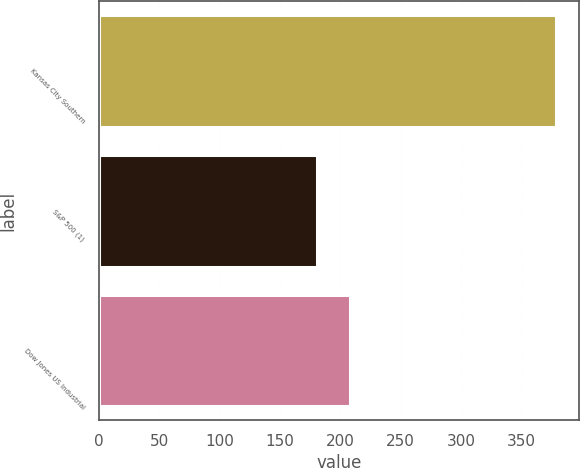Convert chart. <chart><loc_0><loc_0><loc_500><loc_500><bar_chart><fcel>Kansas City Southern<fcel>S&P 500 (1)<fcel>Dow Jones US Industrial<nl><fcel>378.85<fcel>180.44<fcel>207.71<nl></chart> 